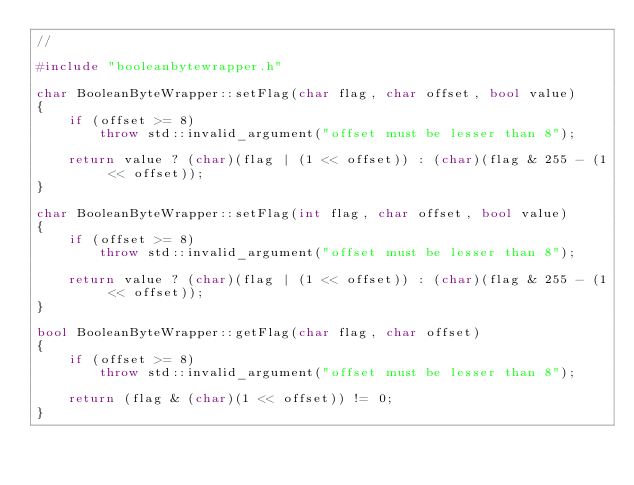<code> <loc_0><loc_0><loc_500><loc_500><_C++_>//

#include "booleanbytewrapper.h"

char BooleanByteWrapper::setFlag(char flag, char offset, bool value)
{
    if (offset >= 8)
        throw std::invalid_argument("offset must be lesser than 8");

    return value ? (char)(flag | (1 << offset)) : (char)(flag & 255 - (1 << offset));
}

char BooleanByteWrapper::setFlag(int flag, char offset, bool value)
{
    if (offset >= 8)
        throw std::invalid_argument("offset must be lesser than 8");

    return value ? (char)(flag | (1 << offset)) : (char)(flag & 255 - (1 << offset));
}

bool BooleanByteWrapper::getFlag(char flag, char offset)
{
    if (offset >= 8)
        throw std::invalid_argument("offset must be lesser than 8");

    return (flag & (char)(1 << offset)) != 0;
}</code> 